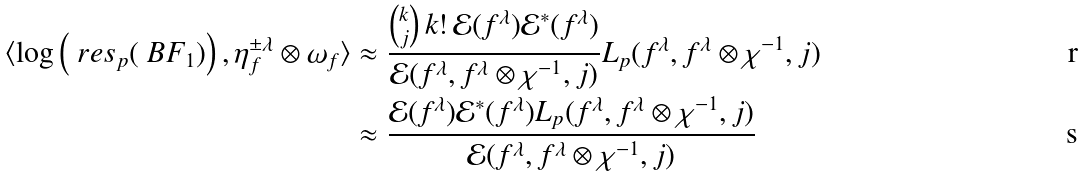<formula> <loc_0><loc_0><loc_500><loc_500>\langle \log \left ( \ r e s _ { p } ( \ B F _ { 1 } ) \right ) , \eta _ { f } ^ { \pm \lambda } \otimes \omega _ { f } \rangle & \approx \frac { { k \choose j } \, k ! \, \mathcal { E } ( f ^ { \lambda } ) { \mathcal { E } ^ { * } ( f ^ { \lambda } ) } } { \mathcal { E } ( f ^ { \lambda } , f ^ { \lambda } \otimes \chi ^ { - 1 } , j ) } L _ { p } ( f ^ { \lambda } , f ^ { \lambda } \otimes \chi ^ { - 1 } , j ) \\ & \approx \frac { \mathcal { E } ( f ^ { \lambda } ) { \mathcal { E } ^ { * } ( f ^ { \lambda } ) } L _ { p } ( f ^ { \lambda } , f ^ { \lambda } \otimes \chi ^ { - 1 } , j ) } { \mathcal { E } ( f ^ { \lambda } , f ^ { \lambda } \otimes \chi ^ { - 1 } , j ) } \,</formula> 